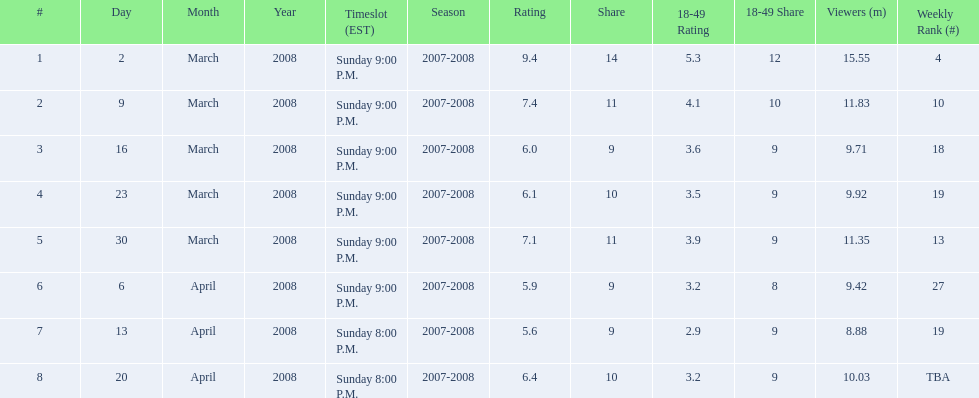How many shows had more than 10 million viewers? 4. 